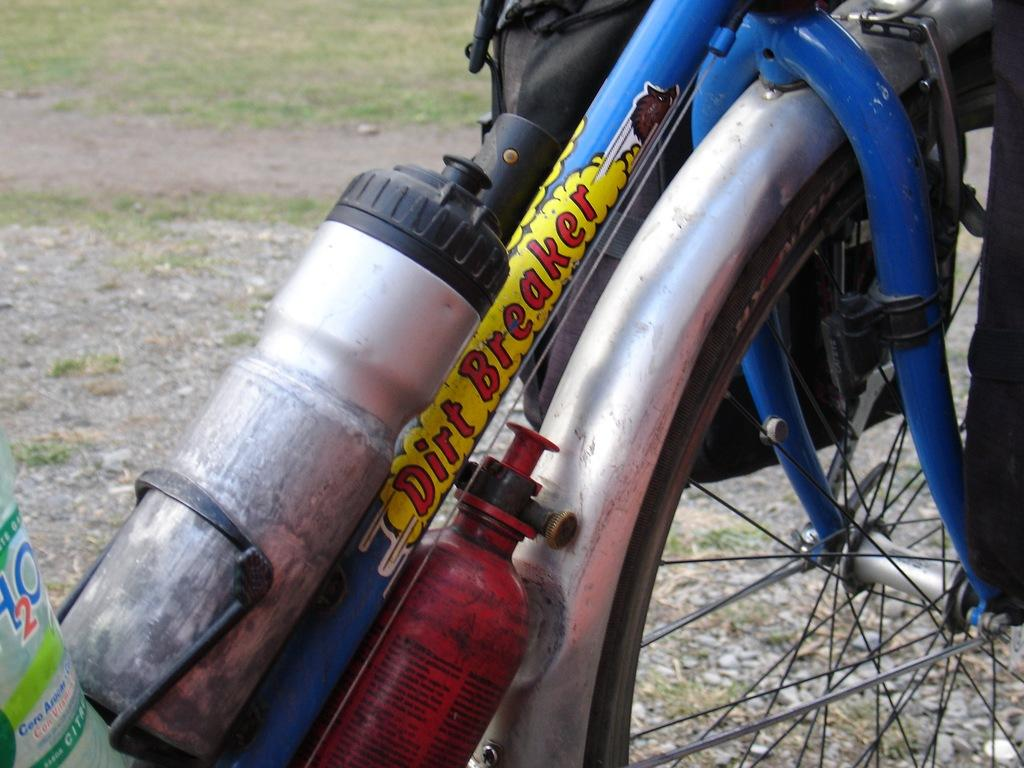What object in the image has spokes or circular parts? There is a wheel in the image that has spokes or circular parts. What can be used to carry items in the image? There is a bag in the image that can be used to carry items. What type of containers are present in the image? There are bottles in the image. How does the beetle interact with the wheel in the image? There is no beetle present in the image, so it cannot interact with the wheel. Can you touch the bottles in the image? The image is two-dimensional, so you cannot physically touch the bottles in the image. 